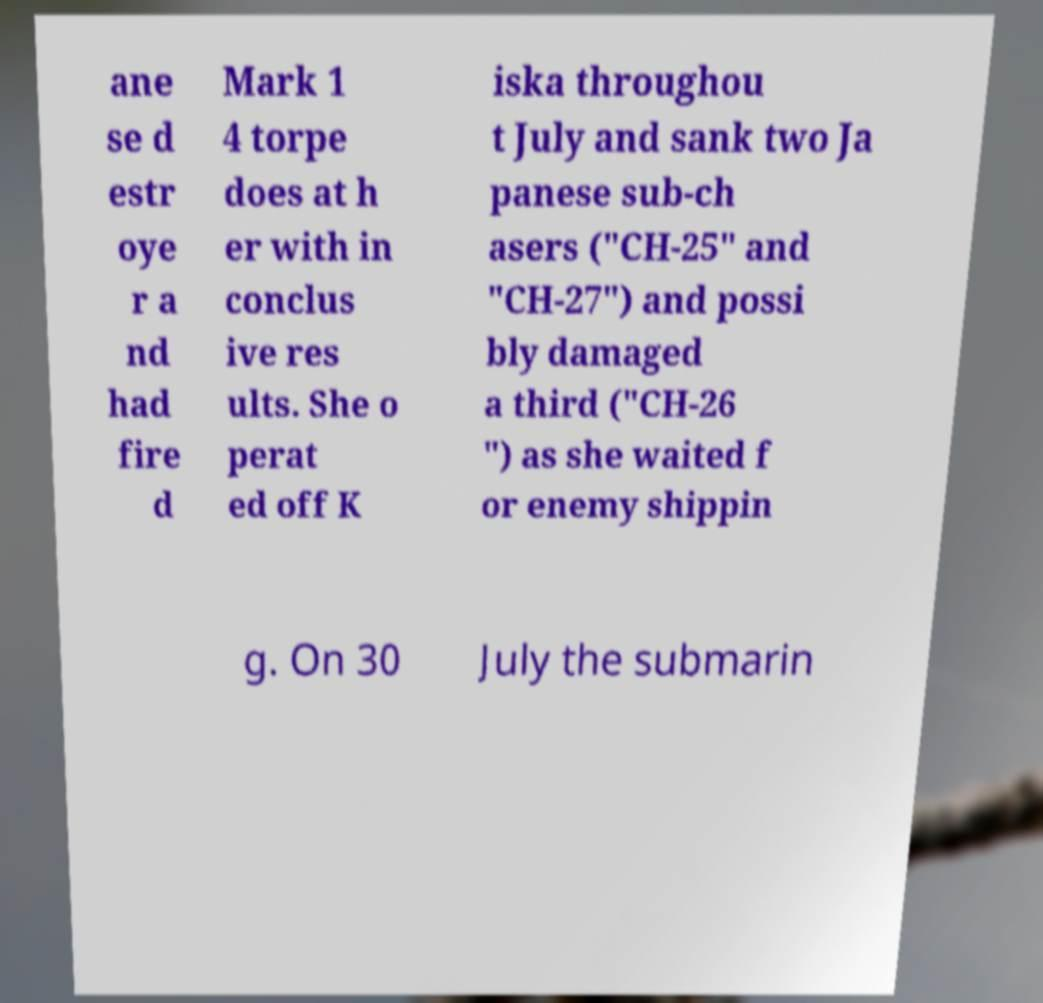Please read and relay the text visible in this image. What does it say? ane se d estr oye r a nd had fire d Mark 1 4 torpe does at h er with in conclus ive res ults. She o perat ed off K iska throughou t July and sank two Ja panese sub-ch asers ("CH-25" and "CH-27") and possi bly damaged a third ("CH-26 ") as she waited f or enemy shippin g. On 30 July the submarin 